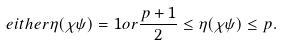Convert formula to latex. <formula><loc_0><loc_0><loc_500><loc_500>e i t h e r \eta ( \chi \psi ) = 1 o r \frac { p + 1 } { 2 } \leq \eta ( \chi \psi ) \leq p .</formula> 